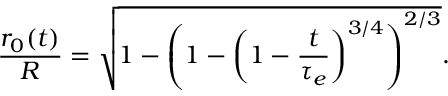Convert formula to latex. <formula><loc_0><loc_0><loc_500><loc_500>\frac { r _ { 0 } ( t ) } { R } = \sqrt { 1 - \left ( 1 - \left ( 1 - \frac { t } { \tau _ { e } } \right ) ^ { 3 / 4 } \right ) ^ { 2 / 3 } } .</formula> 